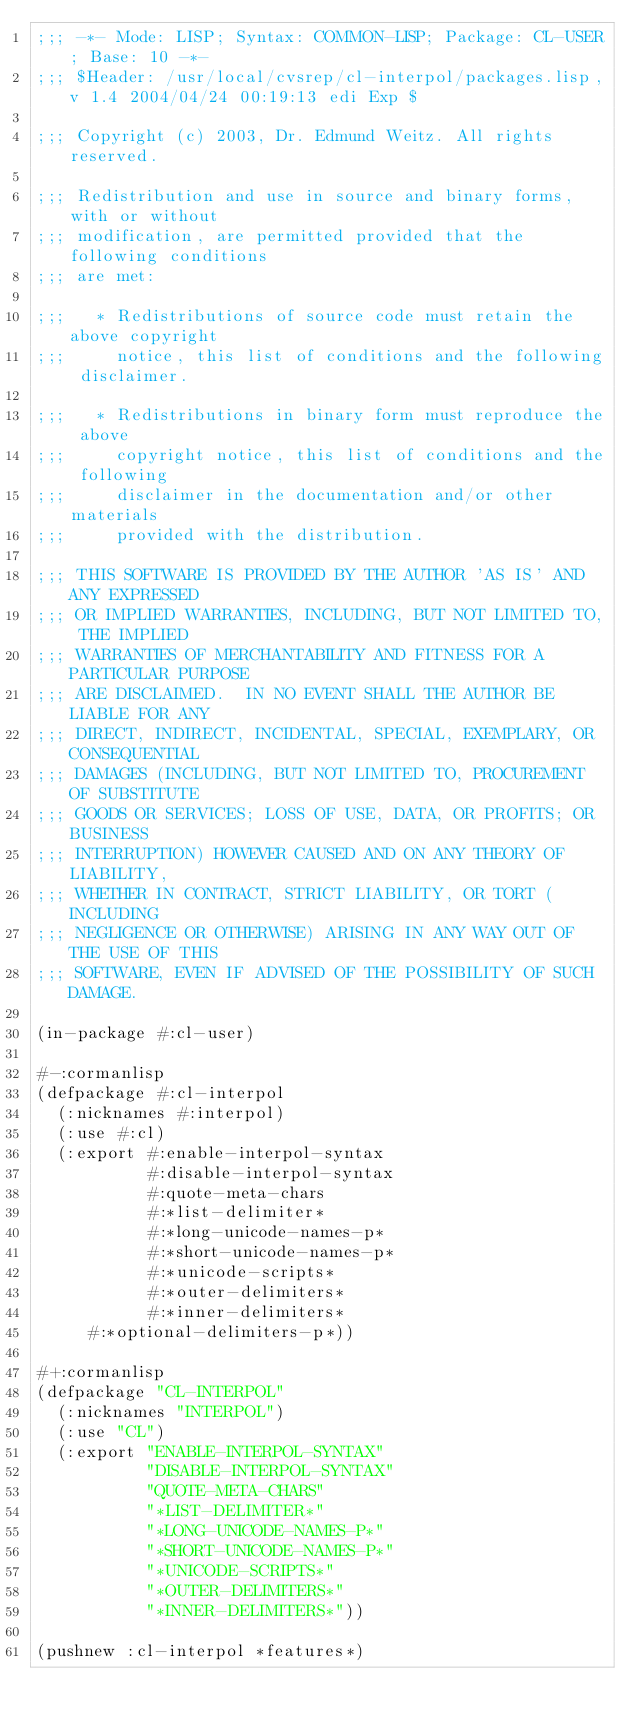<code> <loc_0><loc_0><loc_500><loc_500><_Lisp_>;;; -*- Mode: LISP; Syntax: COMMON-LISP; Package: CL-USER; Base: 10 -*-
;;; $Header: /usr/local/cvsrep/cl-interpol/packages.lisp,v 1.4 2004/04/24 00:19:13 edi Exp $

;;; Copyright (c) 2003, Dr. Edmund Weitz. All rights reserved.

;;; Redistribution and use in source and binary forms, with or without
;;; modification, are permitted provided that the following conditions
;;; are met:

;;;   * Redistributions of source code must retain the above copyright
;;;     notice, this list of conditions and the following disclaimer.

;;;   * Redistributions in binary form must reproduce the above
;;;     copyright notice, this list of conditions and the following
;;;     disclaimer in the documentation and/or other materials
;;;     provided with the distribution.

;;; THIS SOFTWARE IS PROVIDED BY THE AUTHOR 'AS IS' AND ANY EXPRESSED
;;; OR IMPLIED WARRANTIES, INCLUDING, BUT NOT LIMITED TO, THE IMPLIED
;;; WARRANTIES OF MERCHANTABILITY AND FITNESS FOR A PARTICULAR PURPOSE
;;; ARE DISCLAIMED.  IN NO EVENT SHALL THE AUTHOR BE LIABLE FOR ANY
;;; DIRECT, INDIRECT, INCIDENTAL, SPECIAL, EXEMPLARY, OR CONSEQUENTIAL
;;; DAMAGES (INCLUDING, BUT NOT LIMITED TO, PROCUREMENT OF SUBSTITUTE
;;; GOODS OR SERVICES; LOSS OF USE, DATA, OR PROFITS; OR BUSINESS
;;; INTERRUPTION) HOWEVER CAUSED AND ON ANY THEORY OF LIABILITY,
;;; WHETHER IN CONTRACT, STRICT LIABILITY, OR TORT (INCLUDING
;;; NEGLIGENCE OR OTHERWISE) ARISING IN ANY WAY OUT OF THE USE OF THIS
;;; SOFTWARE, EVEN IF ADVISED OF THE POSSIBILITY OF SUCH DAMAGE.

(in-package #:cl-user)

#-:cormanlisp
(defpackage #:cl-interpol
  (:nicknames #:interpol)
  (:use #:cl)
  (:export #:enable-interpol-syntax
           #:disable-interpol-syntax
           #:quote-meta-chars
           #:*list-delimiter*
           #:*long-unicode-names-p*
           #:*short-unicode-names-p*
           #:*unicode-scripts*
           #:*outer-delimiters*
           #:*inner-delimiters*
	   #:*optional-delimiters-p*))

#+:cormanlisp
(defpackage "CL-INTERPOL"
  (:nicknames "INTERPOL")
  (:use "CL")
  (:export "ENABLE-INTERPOL-SYNTAX"
           "DISABLE-INTERPOL-SYNTAX"
           "QUOTE-META-CHARS"
           "*LIST-DELIMITER*"
           "*LONG-UNICODE-NAMES-P*"
           "*SHORT-UNICODE-NAMES-P*"
           "*UNICODE-SCRIPTS*"
           "*OUTER-DELIMITERS*"
           "*INNER-DELIMITERS*"))

(pushnew :cl-interpol *features*)</code> 